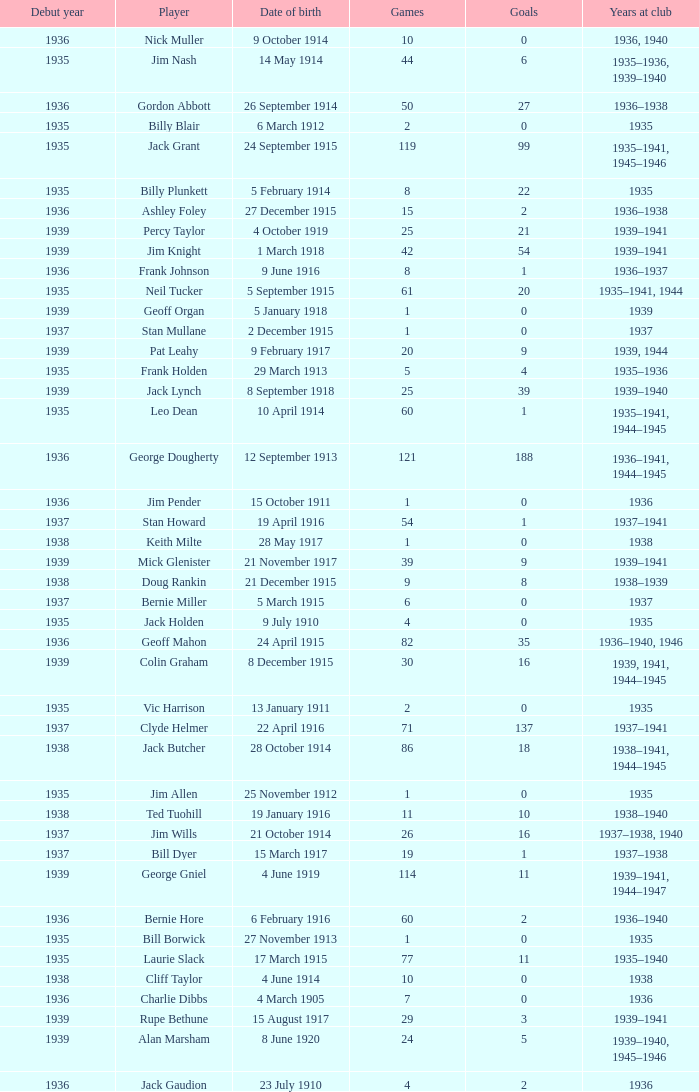For jack gaudion, who began his career in 1936, what was the lowest count of games he played? 4.0. 